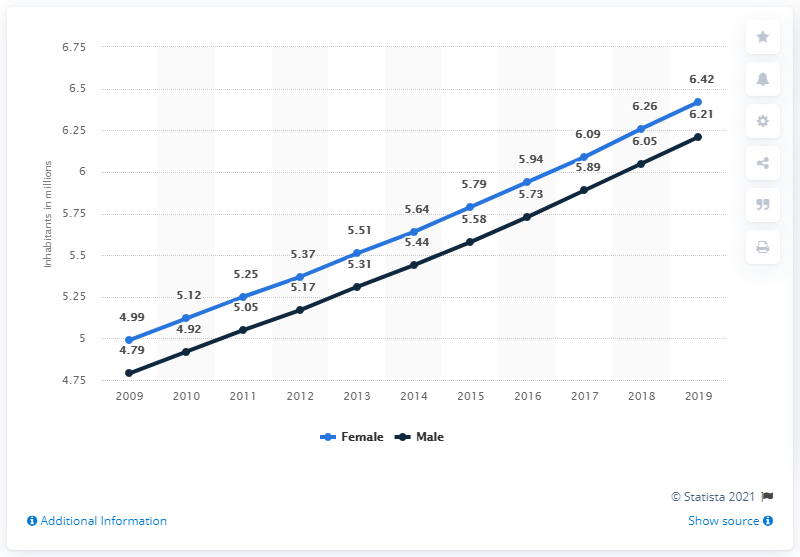Mention a couple of crucial points in this snapshot. In 2019, the male population of Rwanda was estimated to be 6.21 million. As of 2019, the female population of Rwanda was approximately 6.42 million. 